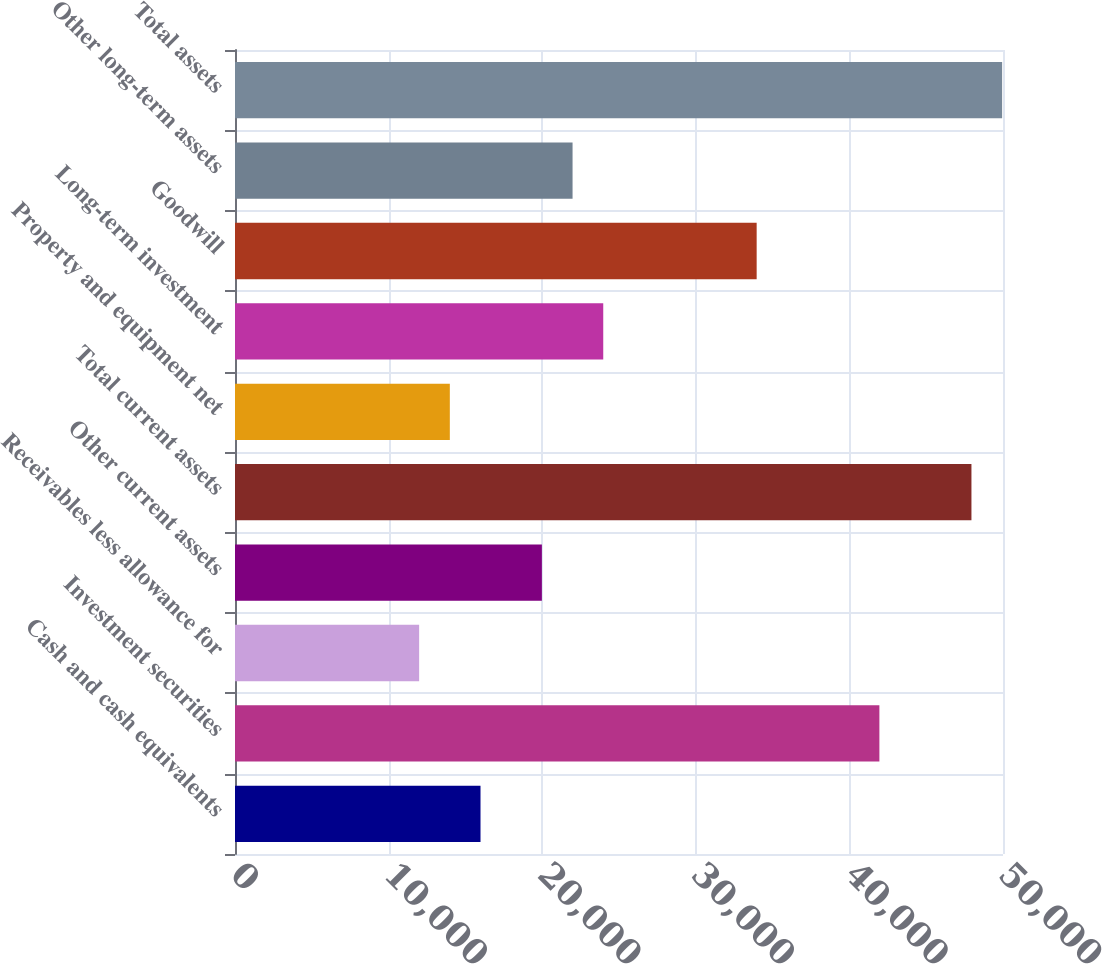Convert chart to OTSL. <chart><loc_0><loc_0><loc_500><loc_500><bar_chart><fcel>Cash and cash equivalents<fcel>Investment securities<fcel>Receivables less allowance for<fcel>Other current assets<fcel>Total current assets<fcel>Property and equipment net<fcel>Long-term investment<fcel>Goodwill<fcel>Other long-term assets<fcel>Total assets<nl><fcel>15983.8<fcel>41952.7<fcel>11988.6<fcel>19979<fcel>47945.6<fcel>13986.2<fcel>23974.2<fcel>33962.3<fcel>21976.6<fcel>49943.2<nl></chart> 